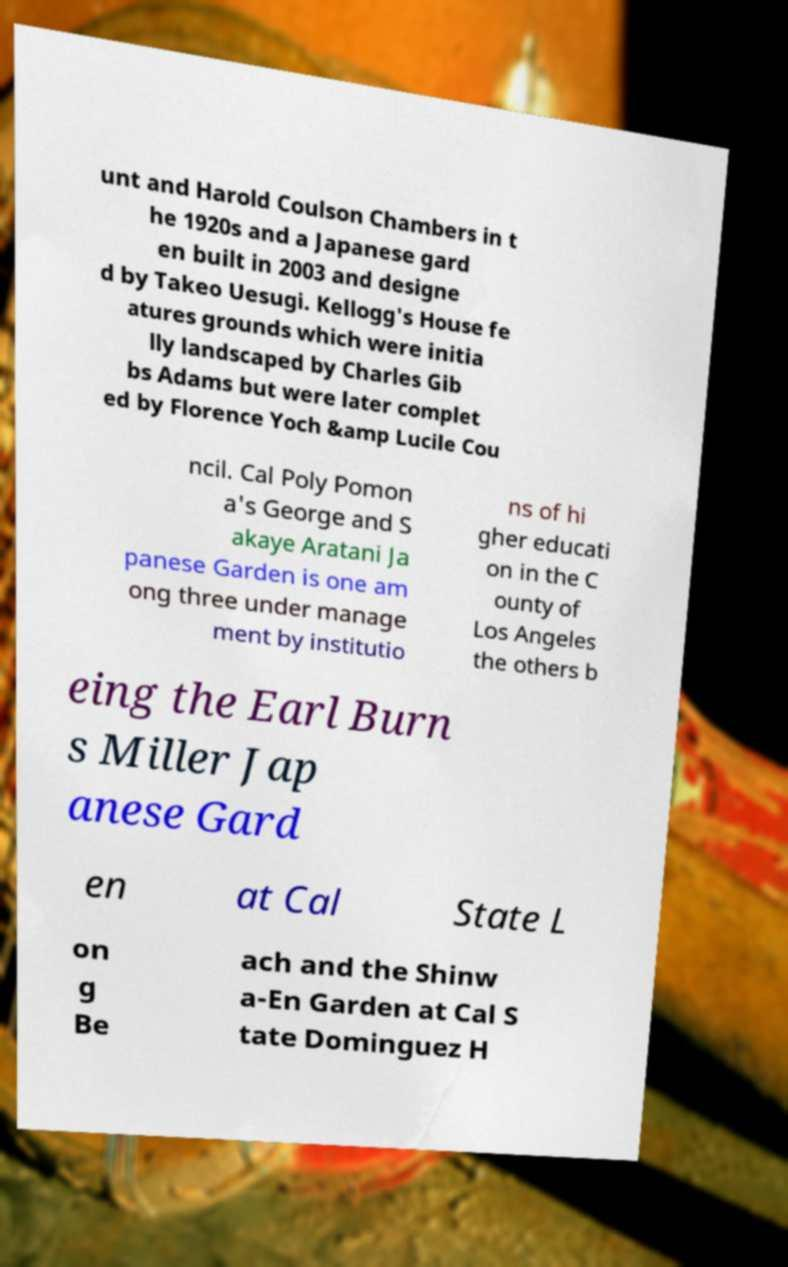I need the written content from this picture converted into text. Can you do that? unt and Harold Coulson Chambers in t he 1920s and a Japanese gard en built in 2003 and designe d by Takeo Uesugi. Kellogg's House fe atures grounds which were initia lly landscaped by Charles Gib bs Adams but were later complet ed by Florence Yoch &amp Lucile Cou ncil. Cal Poly Pomon a's George and S akaye Aratani Ja panese Garden is one am ong three under manage ment by institutio ns of hi gher educati on in the C ounty of Los Angeles the others b eing the Earl Burn s Miller Jap anese Gard en at Cal State L on g Be ach and the Shinw a-En Garden at Cal S tate Dominguez H 